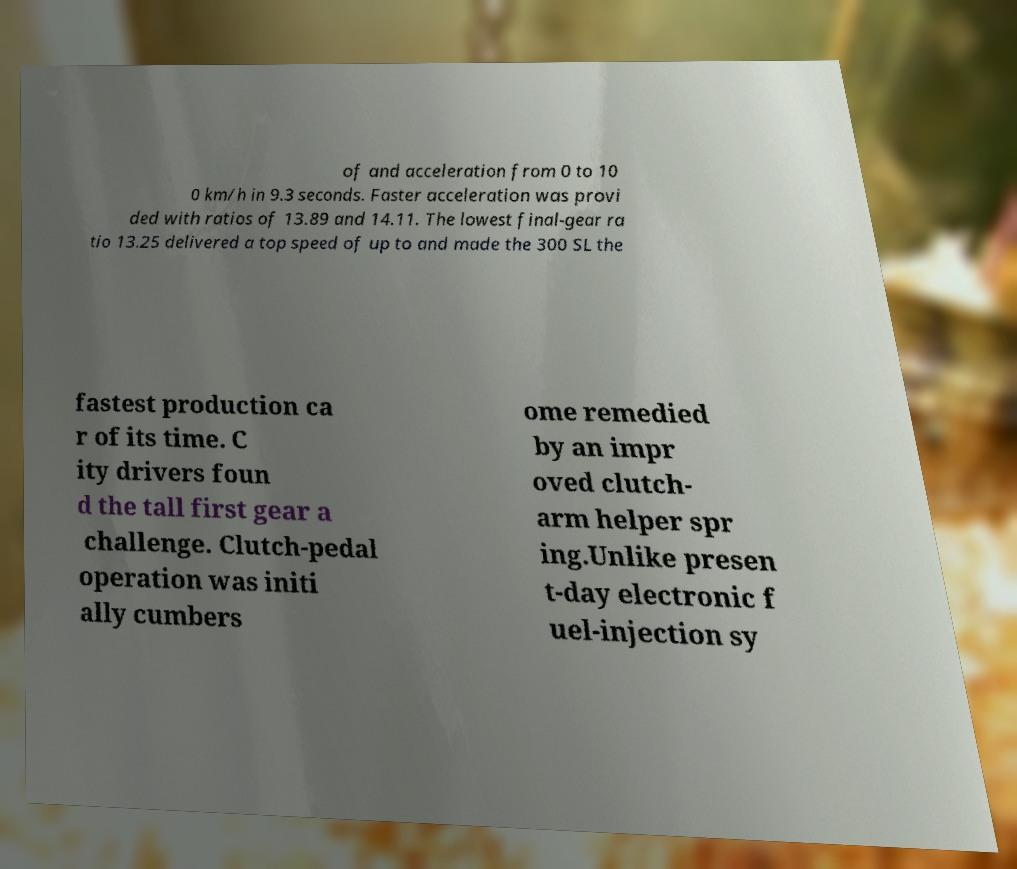Can you read and provide the text displayed in the image?This photo seems to have some interesting text. Can you extract and type it out for me? of and acceleration from 0 to 10 0 km/h in 9.3 seconds. Faster acceleration was provi ded with ratios of 13.89 and 14.11. The lowest final-gear ra tio 13.25 delivered a top speed of up to and made the 300 SL the fastest production ca r of its time. C ity drivers foun d the tall first gear a challenge. Clutch-pedal operation was initi ally cumbers ome remedied by an impr oved clutch- arm helper spr ing.Unlike presen t-day electronic f uel-injection sy 